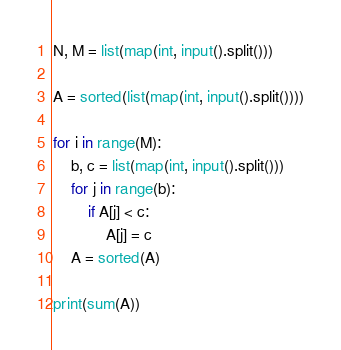<code> <loc_0><loc_0><loc_500><loc_500><_Python_>N, M = list(map(int, input().split()))

A = sorted(list(map(int, input().split())))

for i in range(M):
    b, c = list(map(int, input().split()))
    for j in range(b):
        if A[j] < c:
            A[j] = c
    A = sorted(A)

print(sum(A))</code> 